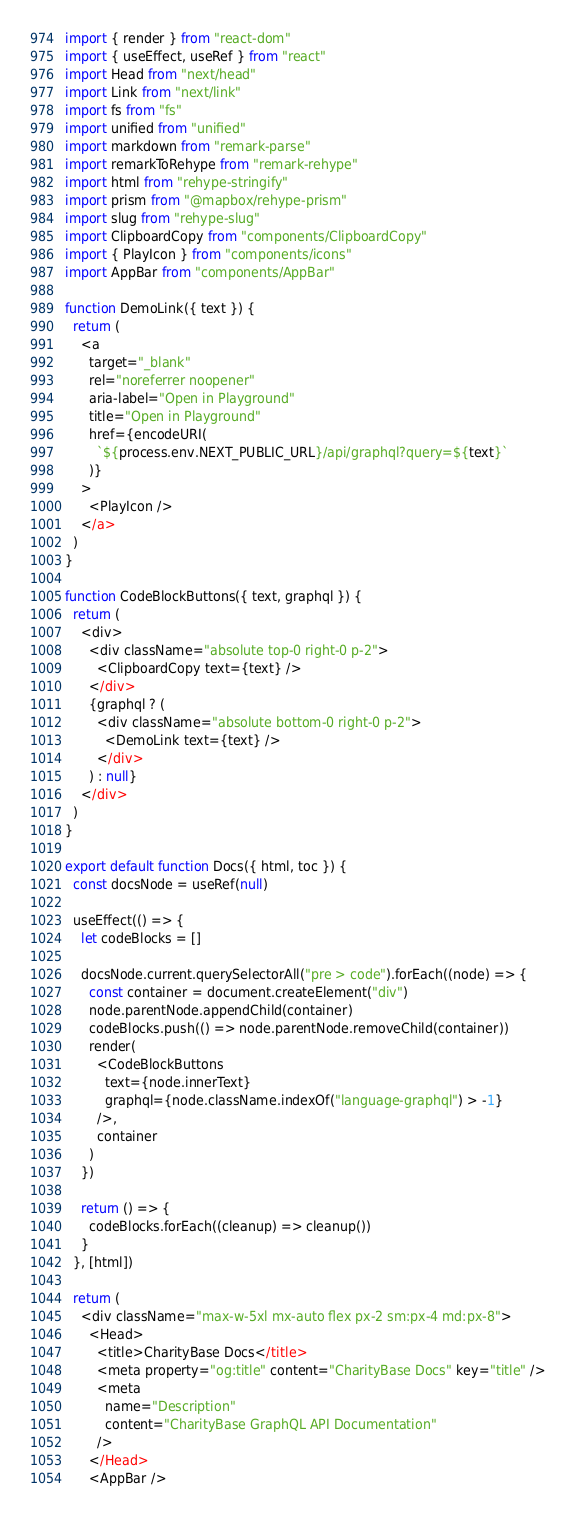<code> <loc_0><loc_0><loc_500><loc_500><_JavaScript_>import { render } from "react-dom"
import { useEffect, useRef } from "react"
import Head from "next/head"
import Link from "next/link"
import fs from "fs"
import unified from "unified"
import markdown from "remark-parse"
import remarkToRehype from "remark-rehype"
import html from "rehype-stringify"
import prism from "@mapbox/rehype-prism"
import slug from "rehype-slug"
import ClipboardCopy from "components/ClipboardCopy"
import { PlayIcon } from "components/icons"
import AppBar from "components/AppBar"

function DemoLink({ text }) {
  return (
    <a
      target="_blank"
      rel="noreferrer noopener"
      aria-label="Open in Playground"
      title="Open in Playground"
      href={encodeURI(
        `${process.env.NEXT_PUBLIC_URL}/api/graphql?query=${text}`
      )}
    >
      <PlayIcon />
    </a>
  )
}

function CodeBlockButtons({ text, graphql }) {
  return (
    <div>
      <div className="absolute top-0 right-0 p-2">
        <ClipboardCopy text={text} />
      </div>
      {graphql ? (
        <div className="absolute bottom-0 right-0 p-2">
          <DemoLink text={text} />
        </div>
      ) : null}
    </div>
  )
}

export default function Docs({ html, toc }) {
  const docsNode = useRef(null)

  useEffect(() => {
    let codeBlocks = []

    docsNode.current.querySelectorAll("pre > code").forEach((node) => {
      const container = document.createElement("div")
      node.parentNode.appendChild(container)
      codeBlocks.push(() => node.parentNode.removeChild(container))
      render(
        <CodeBlockButtons
          text={node.innerText}
          graphql={node.className.indexOf("language-graphql") > -1}
        />,
        container
      )
    })

    return () => {
      codeBlocks.forEach((cleanup) => cleanup())
    }
  }, [html])

  return (
    <div className="max-w-5xl mx-auto flex px-2 sm:px-4 md:px-8">
      <Head>
        <title>CharityBase Docs</title>
        <meta property="og:title" content="CharityBase Docs" key="title" />
        <meta
          name="Description"
          content="CharityBase GraphQL API Documentation"
        />
      </Head>
      <AppBar />
</code> 